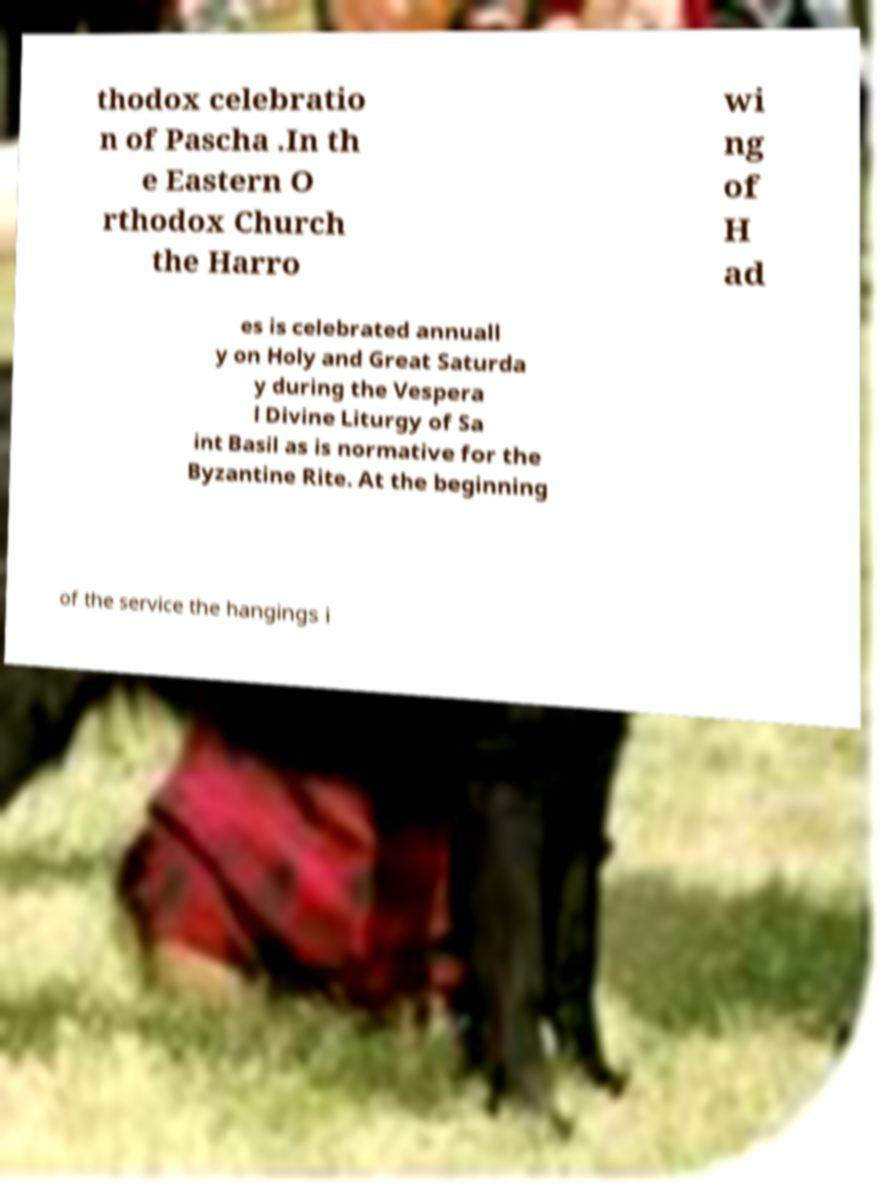I need the written content from this picture converted into text. Can you do that? thodox celebratio n of Pascha .In th e Eastern O rthodox Church the Harro wi ng of H ad es is celebrated annuall y on Holy and Great Saturda y during the Vespera l Divine Liturgy of Sa int Basil as is normative for the Byzantine Rite. At the beginning of the service the hangings i 